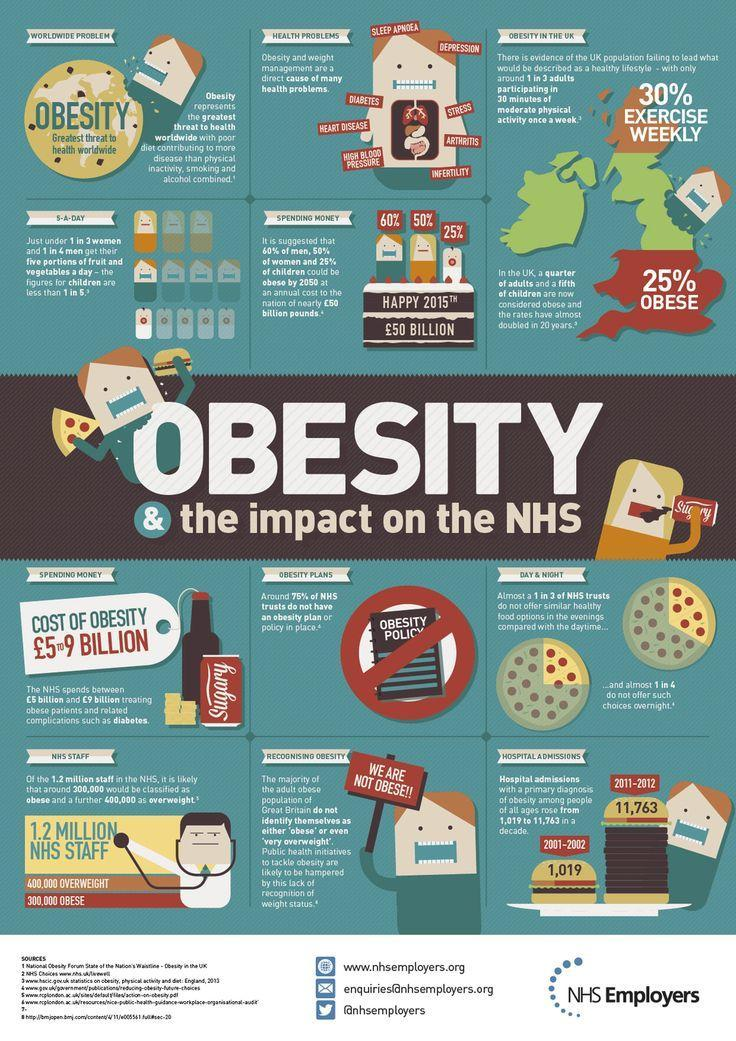Which category of people will be less obese by 2050 among men, women, children?
Answer the question with a short phrase. children How much was the increase in number of Obesity patients from the year 2001 to 2012? 10,744 What percentage of NHS organisations have an obesity plan? 25 